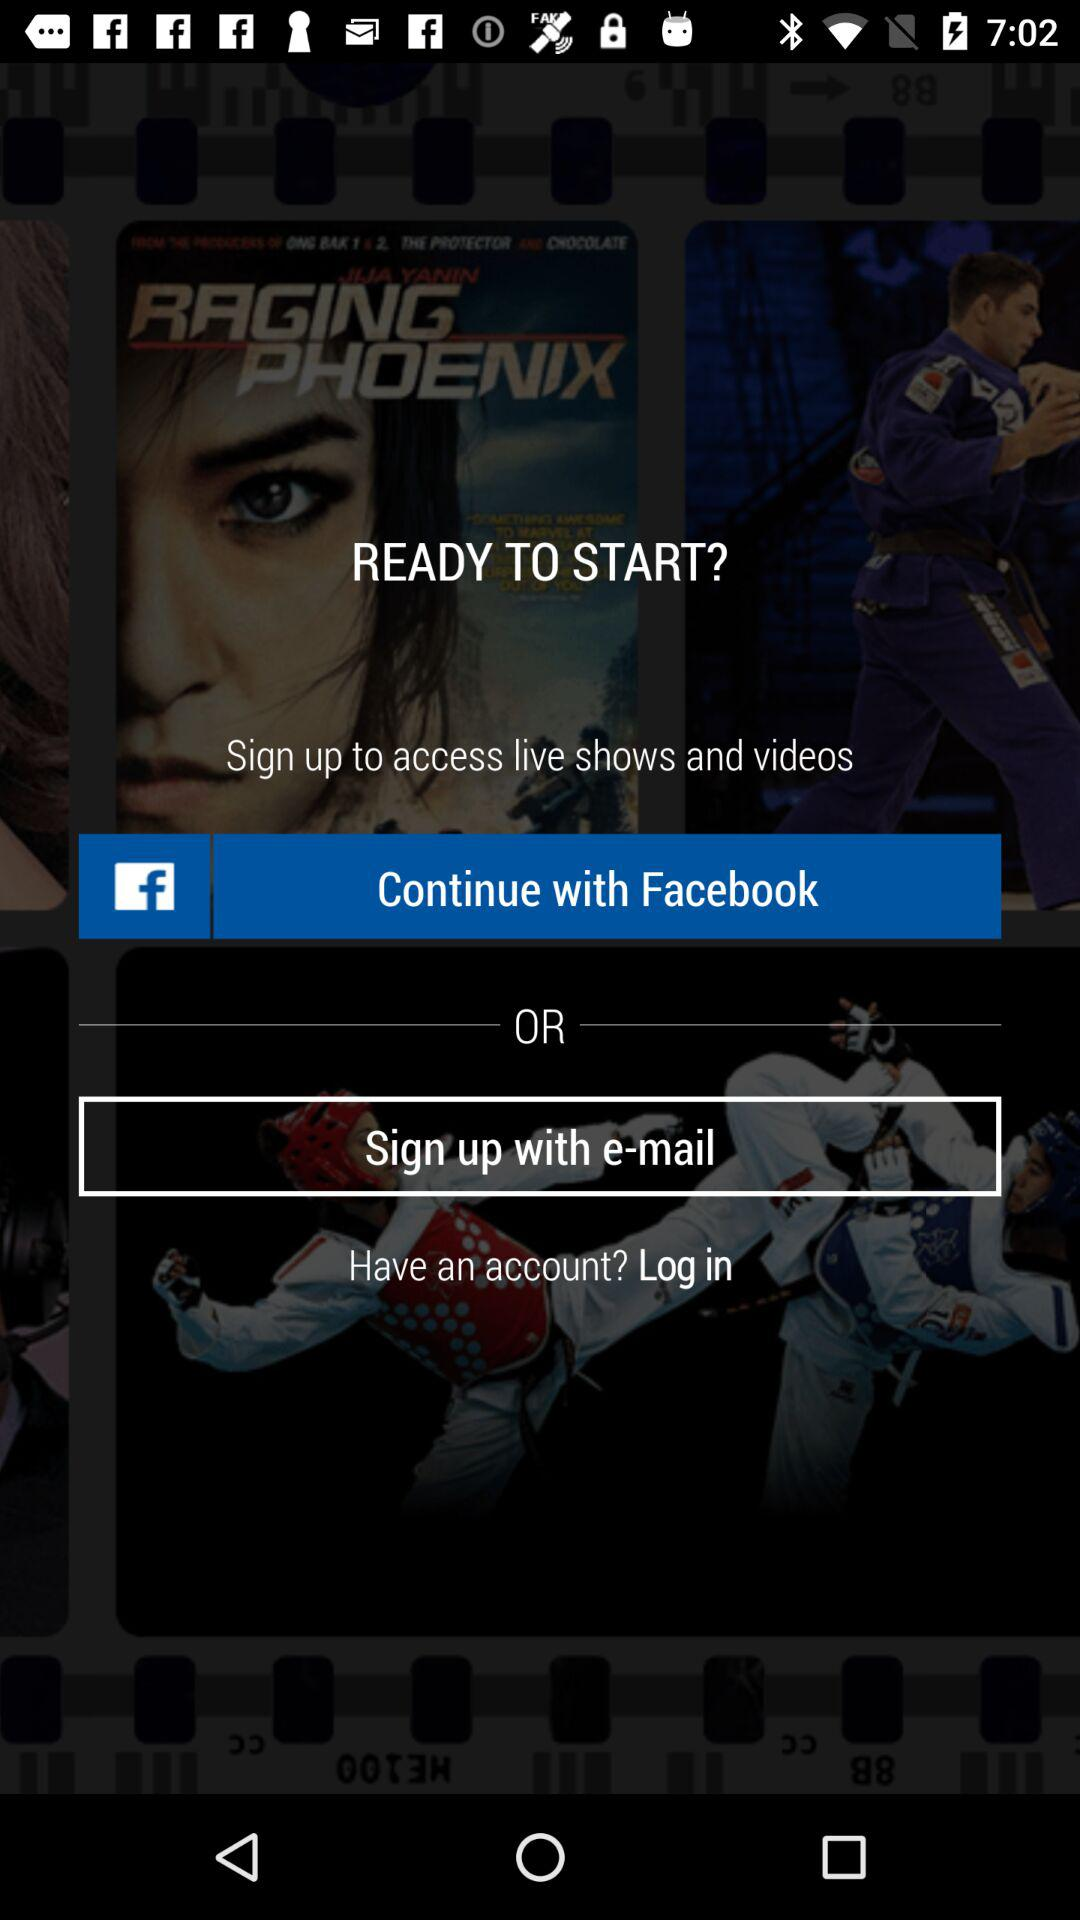What accounts can I use to sign up? You can use "Facebook" and "e-mail". 